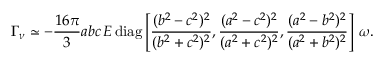<formula> <loc_0><loc_0><loc_500><loc_500>\Gamma _ { \nu } \simeq - \frac { 1 6 \pi } { 3 } a b c \, E \, d i a g \left [ \frac { ( b ^ { 2 } - c ^ { 2 } ) ^ { 2 } } { ( b ^ { 2 } + c ^ { 2 } ) ^ { 2 } } , \frac { ( a ^ { 2 } - c ^ { 2 } ) ^ { 2 } } { ( a ^ { 2 } + c ^ { 2 } ) ^ { 2 } } , \frac { ( a ^ { 2 } - b ^ { 2 } ) ^ { 2 } } { ( a ^ { 2 } + b ^ { 2 } ) ^ { 2 } } \right ] \, \omega .</formula> 